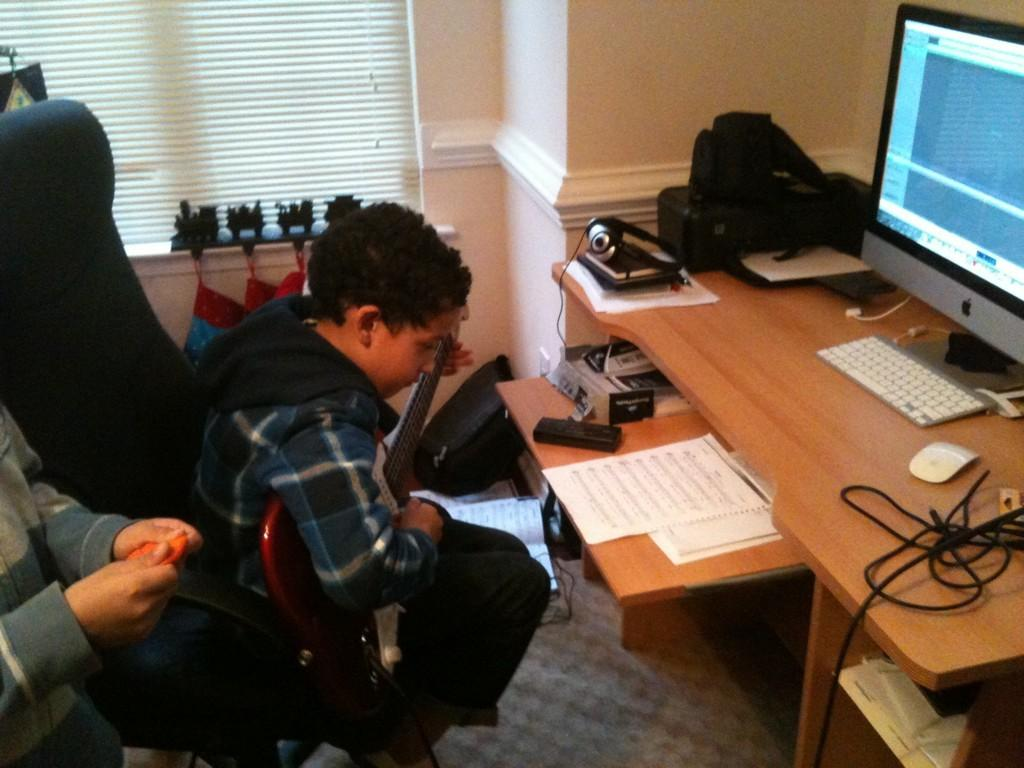What is the man in the image doing? The man is playing a guitar. What is the man sitting on in the image? The man is sitting on a chair. What objects can be seen on the table in the image? There are papers, a keyboard, a mouse, a monitor, a cable, and other things on the table. What is visible outside the window in the image? The facts provided do not mention anything about the view outside the window. How many objects are on the table in the image? There are at least six objects mentioned on the table: papers, a keyboard, a mouse, a monitor, a cable, and other things. What type of shoes is the man wearing in the image? The facts provided do not mention anything about the man's shoes. What material is the lead used for in the image? There is no mention of lead or any material related to lead in the image. 